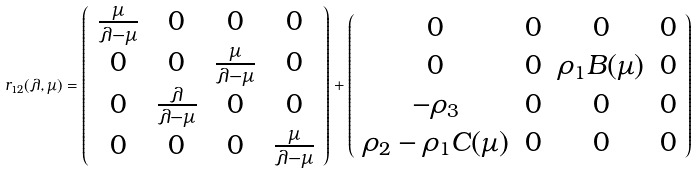<formula> <loc_0><loc_0><loc_500><loc_500>r _ { 1 2 } ( \lambda , \mu ) = \left ( \begin{array} { c c c c } \frac { \mu } { \lambda - \mu } & 0 & 0 & 0 \\ 0 & 0 & \frac { \mu } { \lambda - \mu } & 0 \\ 0 & \frac { \lambda } { \lambda - \mu } & 0 & 0 \\ 0 & 0 & 0 & \frac { \mu } { \lambda - \mu } \end{array} \right ) + \left ( \begin{array} { c c c c } 0 & 0 & 0 & 0 \\ 0 & 0 & \rho _ { 1 } B ( \mu ) & 0 \\ - \rho _ { 3 } & 0 & 0 & 0 \\ \rho _ { 2 } - \rho _ { 1 } C ( \mu ) & 0 & 0 & 0 \end{array} \right )</formula> 